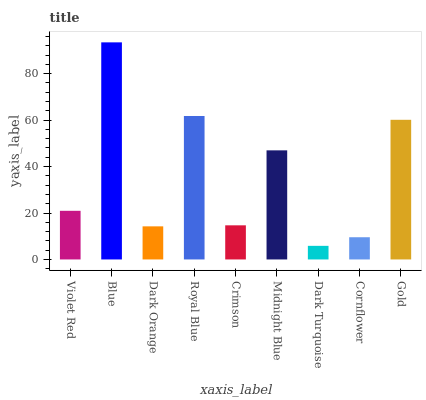Is Dark Turquoise the minimum?
Answer yes or no. Yes. Is Blue the maximum?
Answer yes or no. Yes. Is Dark Orange the minimum?
Answer yes or no. No. Is Dark Orange the maximum?
Answer yes or no. No. Is Blue greater than Dark Orange?
Answer yes or no. Yes. Is Dark Orange less than Blue?
Answer yes or no. Yes. Is Dark Orange greater than Blue?
Answer yes or no. No. Is Blue less than Dark Orange?
Answer yes or no. No. Is Violet Red the high median?
Answer yes or no. Yes. Is Violet Red the low median?
Answer yes or no. Yes. Is Midnight Blue the high median?
Answer yes or no. No. Is Royal Blue the low median?
Answer yes or no. No. 